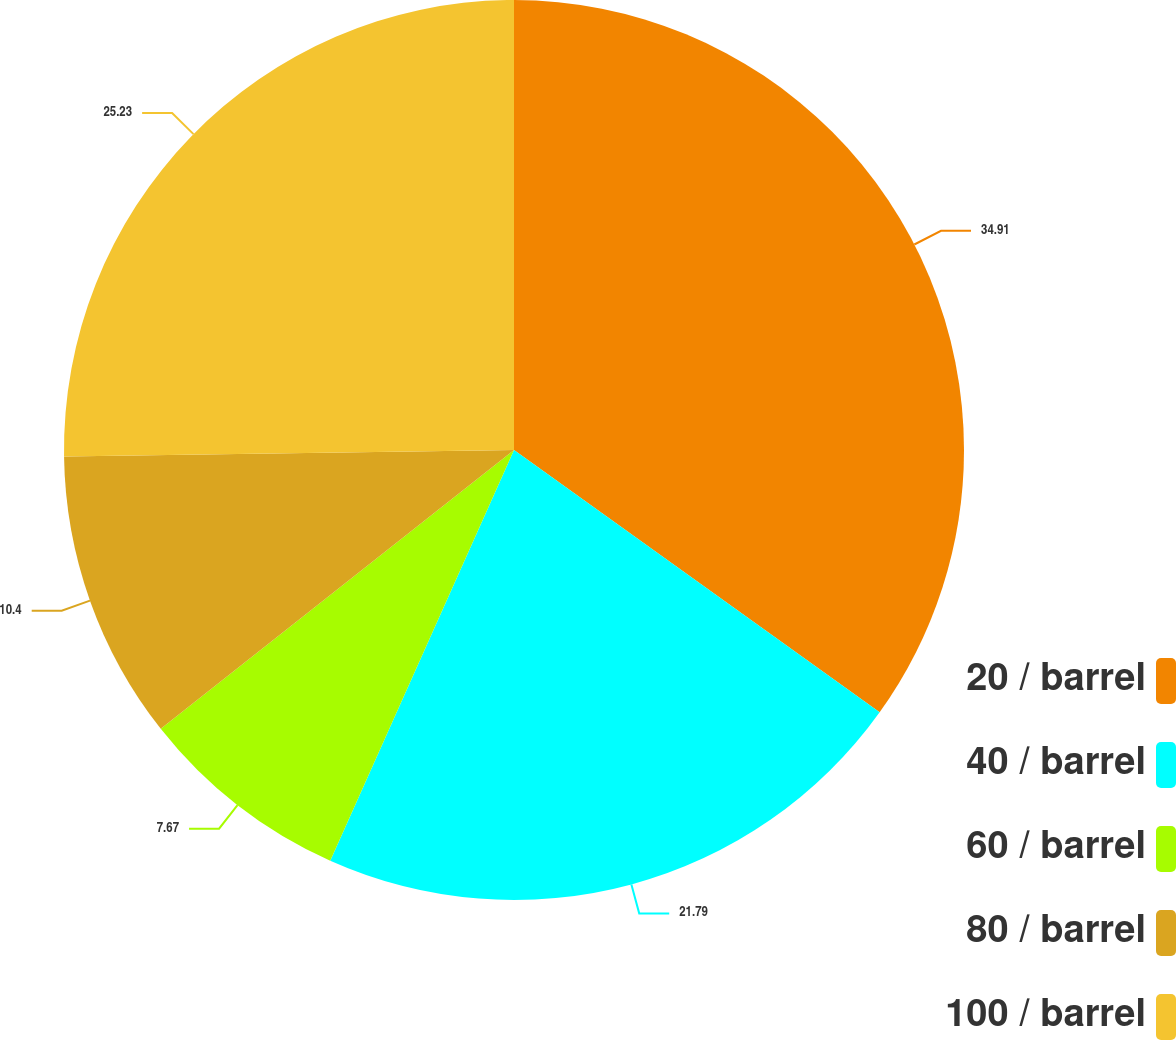<chart> <loc_0><loc_0><loc_500><loc_500><pie_chart><fcel>20 / barrel<fcel>40 / barrel<fcel>60 / barrel<fcel>80 / barrel<fcel>100 / barrel<nl><fcel>34.9%<fcel>21.79%<fcel>7.67%<fcel>10.4%<fcel>25.23%<nl></chart> 